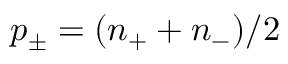<formula> <loc_0><loc_0><loc_500><loc_500>p _ { \pm } = ( n _ { + } + n _ { - } ) / 2</formula> 